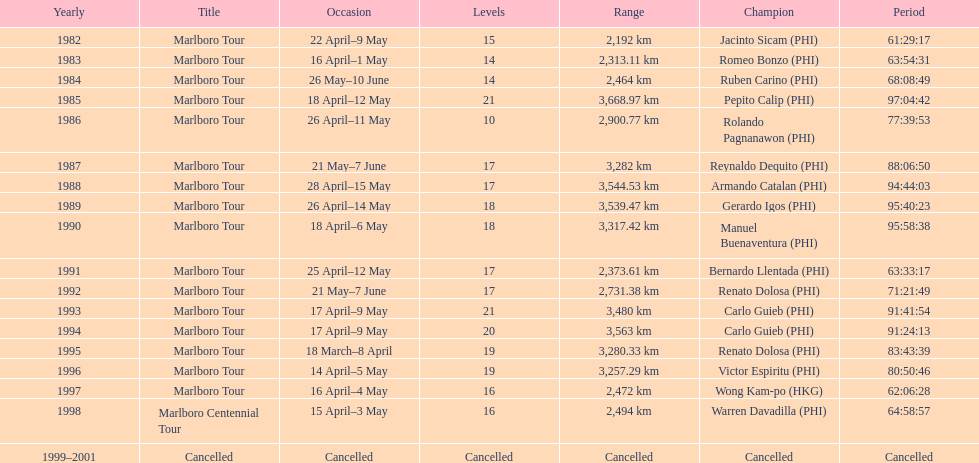Who won the most marlboro tours? Carlo Guieb. 